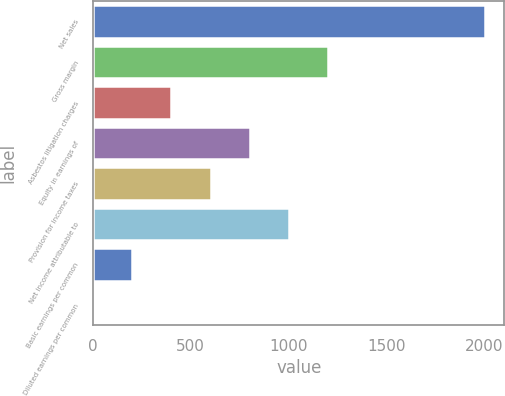Convert chart to OTSL. <chart><loc_0><loc_0><loc_500><loc_500><bar_chart><fcel>Net sales<fcel>Gross margin<fcel>Asbestos litigation charges<fcel>Equity in earnings of<fcel>Provision for income taxes<fcel>Net income attributable to<fcel>Basic earnings per common<fcel>Diluted earnings per common<nl><fcel>2005<fcel>1203.17<fcel>401.37<fcel>802.27<fcel>601.82<fcel>1002.72<fcel>200.92<fcel>0.47<nl></chart> 